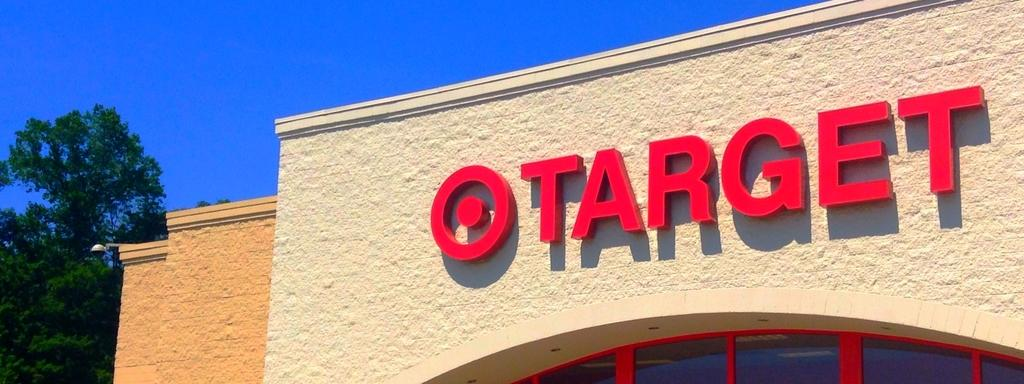What type of structure is visible in the image? There is a building in the image. What natural element can be seen in the image? There is a tree in the image. What color is the sky in the image? The sky is blue in the image. What type of cherries are being used to flavor the lettuce in the image? There is no lettuce or cherries present in the image. 